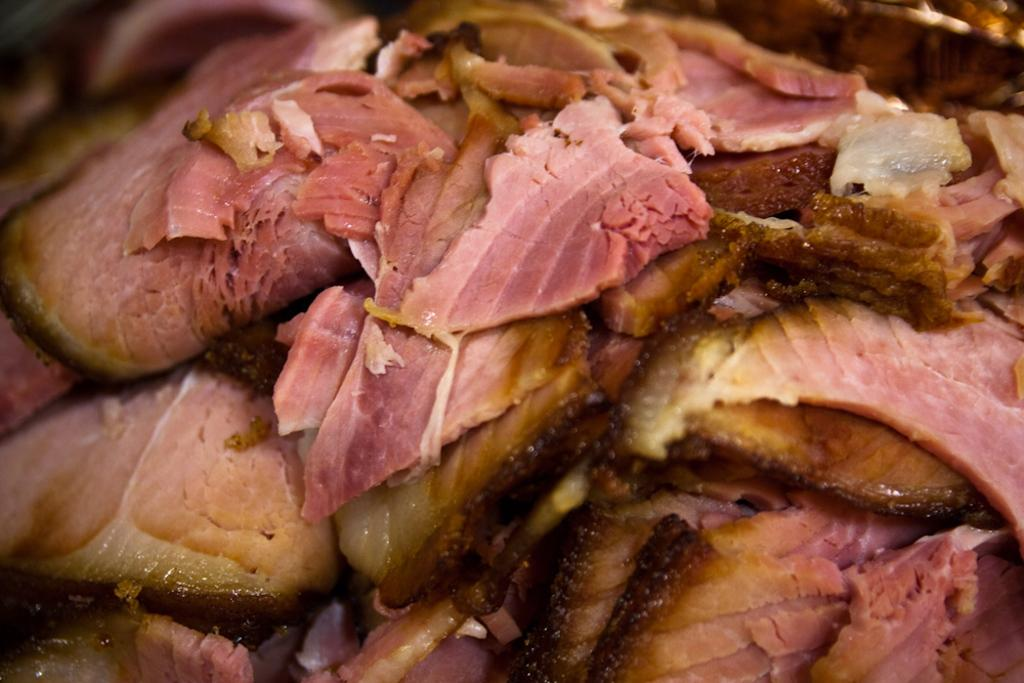What type of food is present in the image? There is meat in the image. What type of bird is sitting on your dad's shoulder during their journey in the image? There is no bird, dad, or journey present in the image; it only features meat. 